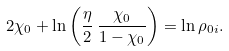<formula> <loc_0><loc_0><loc_500><loc_500>2 \chi _ { 0 } + \ln \left ( \frac { \eta } { 2 } \, \frac { \chi _ { 0 } } { 1 - \chi _ { 0 } } \right ) = \ln \rho _ { 0 i } .</formula> 